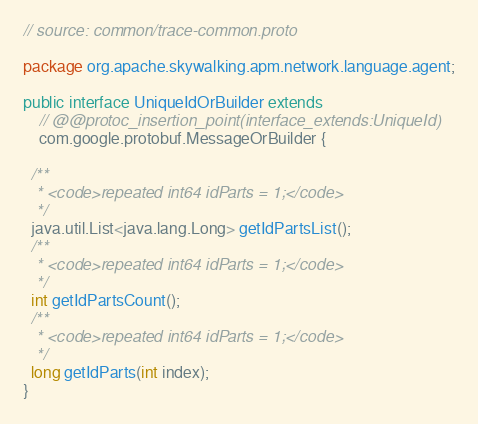Convert code to text. <code><loc_0><loc_0><loc_500><loc_500><_Java_>// source: common/trace-common.proto

package org.apache.skywalking.apm.network.language.agent;

public interface UniqueIdOrBuilder extends
    // @@protoc_insertion_point(interface_extends:UniqueId)
    com.google.protobuf.MessageOrBuilder {

  /**
   * <code>repeated int64 idParts = 1;</code>
   */
  java.util.List<java.lang.Long> getIdPartsList();
  /**
   * <code>repeated int64 idParts = 1;</code>
   */
  int getIdPartsCount();
  /**
   * <code>repeated int64 idParts = 1;</code>
   */
  long getIdParts(int index);
}
</code> 